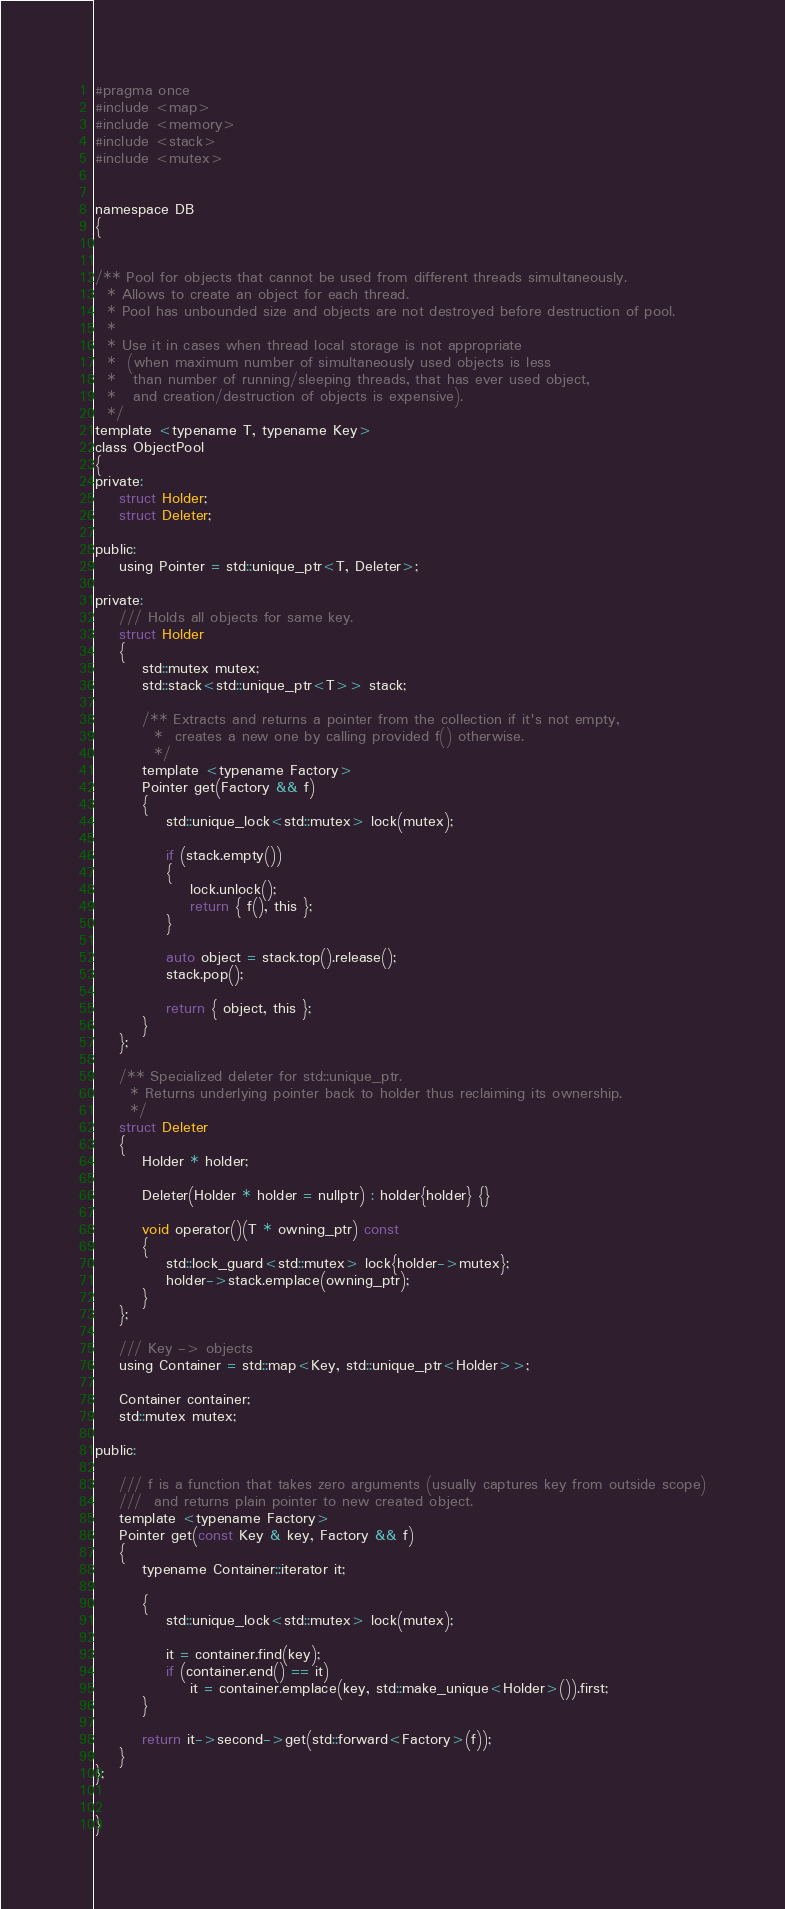Convert code to text. <code><loc_0><loc_0><loc_500><loc_500><_C_>#pragma once
#include <map>
#include <memory>
#include <stack>
#include <mutex>


namespace DB
{


/** Pool for objects that cannot be used from different threads simultaneously.
  * Allows to create an object for each thread.
  * Pool has unbounded size and objects are not destroyed before destruction of pool.
  *
  * Use it in cases when thread local storage is not appropriate
  *  (when maximum number of simultaneously used objects is less
  *   than number of running/sleeping threads, that has ever used object,
  *   and creation/destruction of objects is expensive).
  */
template <typename T, typename Key>
class ObjectPool
{
private:
	struct Holder;
	struct Deleter;

public:
	using Pointer = std::unique_ptr<T, Deleter>;

private:
	///	Holds all objects for same key.
	struct Holder
	{
		std::mutex mutex;
		std::stack<std::unique_ptr<T>> stack;

		/**	Extracts and returns a pointer from the collection if it's not empty,
		  *	 creates a new one by calling provided f() otherwise.
		  */
		template <typename Factory>
		Pointer get(Factory && f)
		{
			std::unique_lock<std::mutex> lock(mutex);

			if (stack.empty())
			{
				lock.unlock();
				return { f(), this };
			}

			auto object = stack.top().release();
			stack.pop();

			return { object, this };
		}
	};

	/**	Specialized deleter for std::unique_ptr.
	  *	Returns underlying pointer back to holder thus reclaiming its ownership.
	  */
	struct Deleter
	{
		Holder * holder;

		Deleter(Holder * holder = nullptr) : holder{holder} {}

		void operator()(T * owning_ptr) const
		{
			std::lock_guard<std::mutex> lock{holder->mutex};
			holder->stack.emplace(owning_ptr);
		}
	};

	/// Key -> objects
	using Container = std::map<Key, std::unique_ptr<Holder>>;

	Container container;
	std::mutex mutex;

public:

	/// f is a function that takes zero arguments (usually captures key from outside scope)
	///  and returns plain pointer to new created object.
	template <typename Factory>
	Pointer get(const Key & key, Factory && f)
	{
		typename Container::iterator it;

		{
			std::unique_lock<std::mutex> lock(mutex);

			it = container.find(key);
			if (container.end() == it)
				it = container.emplace(key, std::make_unique<Holder>()).first;
		}

		return it->second->get(std::forward<Factory>(f));
	}
};


}
</code> 